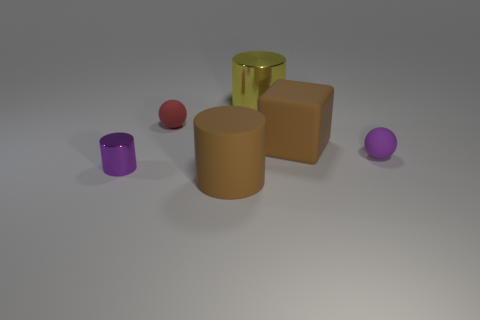Add 2 big yellow metallic objects. How many objects exist? 8 Subtract all metallic cylinders. How many cylinders are left? 1 Subtract all brown cylinders. How many cylinders are left? 2 Subtract 3 cylinders. How many cylinders are left? 0 Subtract all cyan cubes. How many green balls are left? 0 Add 4 yellow metallic cylinders. How many yellow metallic cylinders are left? 5 Add 6 brown rubber objects. How many brown rubber objects exist? 8 Subtract 0 cyan spheres. How many objects are left? 6 Subtract all cubes. How many objects are left? 5 Subtract all cyan cylinders. Subtract all gray blocks. How many cylinders are left? 3 